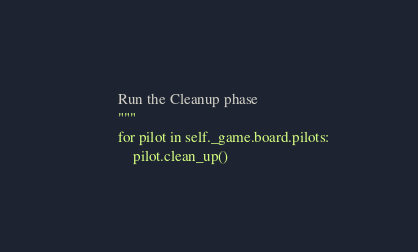Convert code to text. <code><loc_0><loc_0><loc_500><loc_500><_Python_>        Run the Cleanup phase
        """
        for pilot in self._game.board.pilots:
            pilot.clean_up()
</code> 